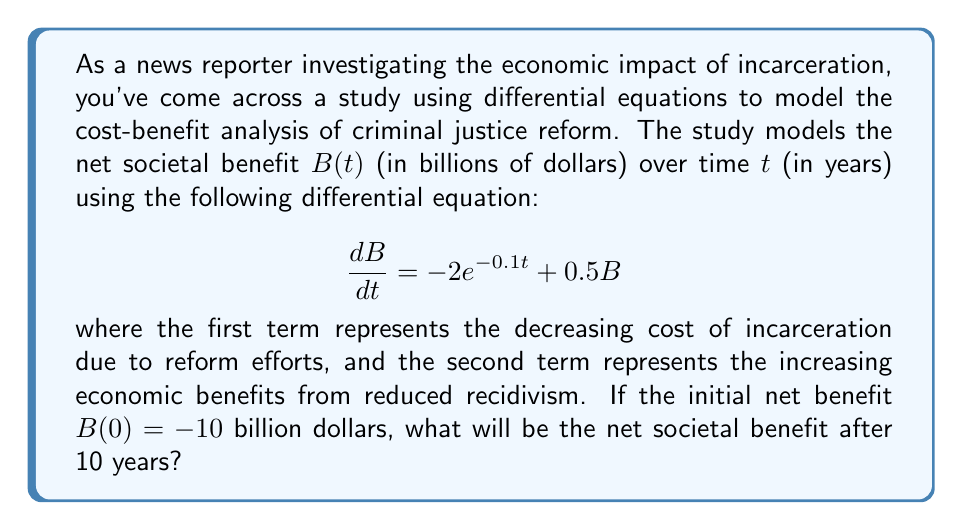Teach me how to tackle this problem. To solve this problem, we need to follow these steps:

1) We have a first-order linear differential equation:

   $$\frac{dB}{dt} = -2e^{-0.1t} + 0.5B$$

2) The general solution for this type of equation is:

   $$B(t) = e^{0.5t}(C - 2\int e^{-0.6t}dt)$$

   where $C$ is a constant of integration.

3) Solving the integral:

   $$\int e^{-0.6t}dt = -\frac{1}{0.6}e^{-0.6t} + K$$

4) Substituting back:

   $$B(t) = e^{0.5t}(C + \frac{10}{3}e^{-0.6t})$$

5) Using the initial condition $B(0) = -10$:

   $$-10 = C + \frac{10}{3}$$
   $$C = -\frac{40}{3}$$

6) Our particular solution is:

   $$B(t) = e^{0.5t}(-\frac{40}{3} + \frac{10}{3}e^{-0.6t})$$

7) To find $B(10)$, we substitute $t=10$:

   $$B(10) = e^{5}(-\frac{40}{3} + \frac{10}{3}e^{-6})$$

8) Calculating this value:

   $$B(10) \approx 148.41$$

Therefore, after 10 years, the net societal benefit will be approximately 148.41 billion dollars.
Answer: $148.41 billion 